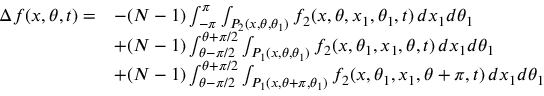Convert formula to latex. <formula><loc_0><loc_0><loc_500><loc_500>\begin{array} { r l } { \Delta f ( x , \theta , t ) = } & { - ( N - 1 ) \int _ { - \pi } ^ { \pi } \int _ { P _ { 2 } ( x , \theta , \theta _ { 1 } ) } f _ { 2 } ( x , \theta , x _ { 1 } , \theta _ { 1 } , t ) \, d x _ { 1 } d \theta _ { 1 } } \\ & { + ( N - 1 ) \int _ { \theta - \pi / 2 } ^ { \theta + \pi / 2 } \int _ { P _ { 1 } ( x , \theta , \theta _ { 1 } ) } f _ { 2 } ( x , \theta _ { 1 } , x _ { 1 } , \theta , t ) \, d x _ { 1 } d \theta _ { 1 } } \\ & { + ( N - 1 ) \int _ { \theta - \pi / 2 } ^ { \theta + \pi / 2 } \int _ { P _ { 1 } ( x , \theta + \pi , \theta _ { 1 } ) } f _ { 2 } ( x , \theta _ { 1 } , x _ { 1 } , \theta + \pi , t ) \, d x _ { 1 } d \theta _ { 1 } } \end{array}</formula> 